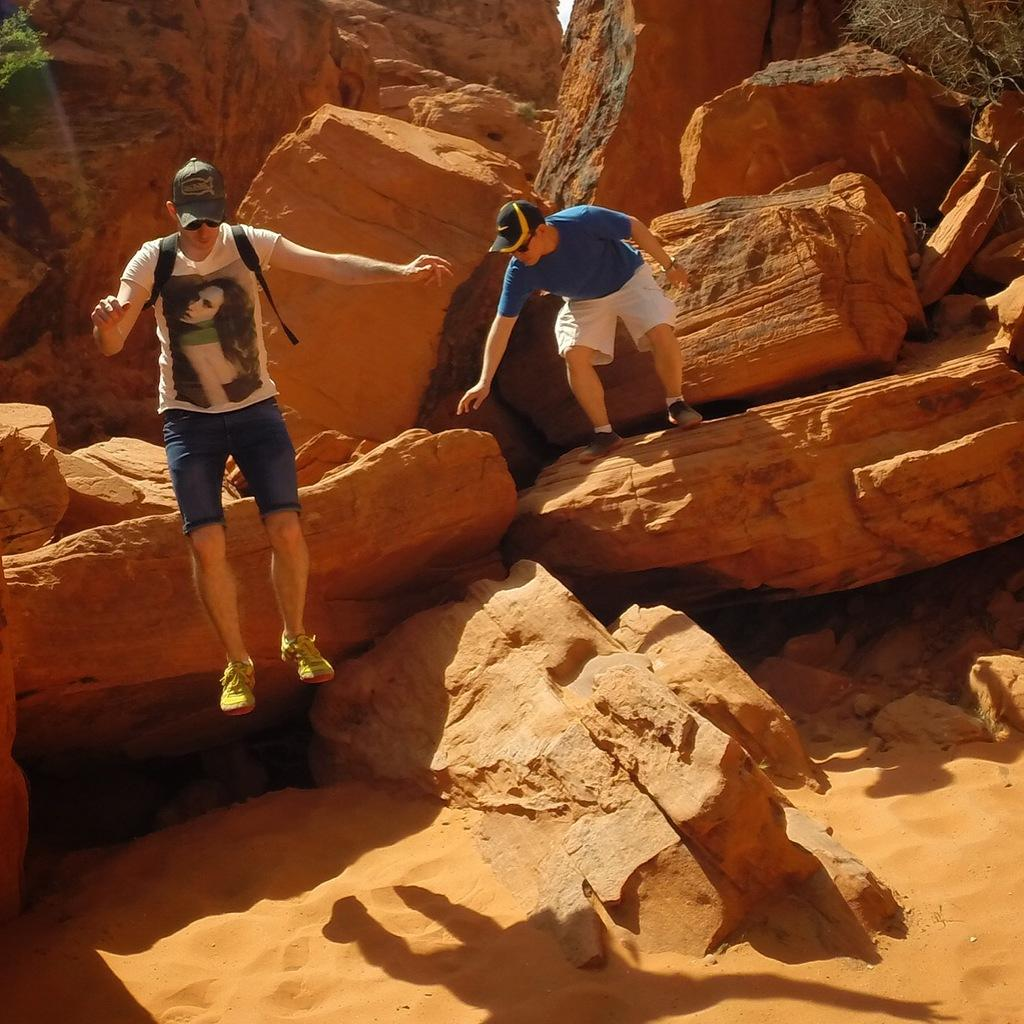What is the setting of the image? The image is an outside view. What type of terrain is visible in the image? There are many rocks and sand in the image. What is the man on the left side of the image doing? There is a man jumping on the left side of the image. Can you describe the position of the other man in the image? There is another man standing on a rock on the left side of the image. What year is depicted in the image? The image does not depict a specific year; it is a general outside view. What type of form does the crow have in the image? There is no crow present in the image. 